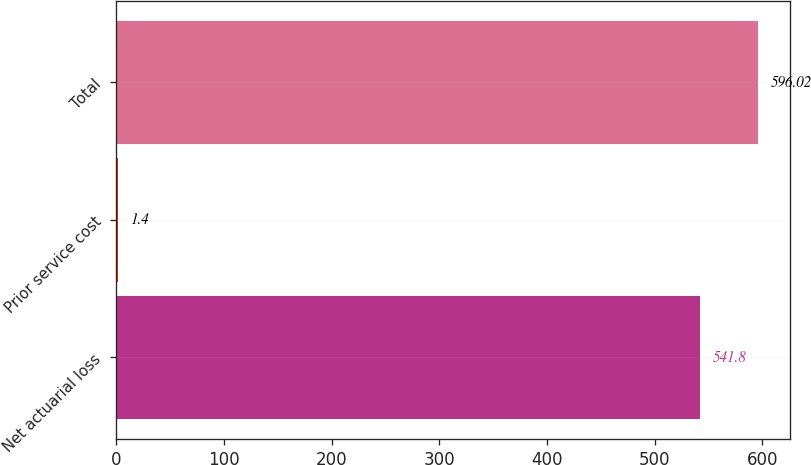<chart> <loc_0><loc_0><loc_500><loc_500><bar_chart><fcel>Net actuarial loss<fcel>Prior service cost<fcel>Total<nl><fcel>541.8<fcel>1.4<fcel>596.02<nl></chart> 